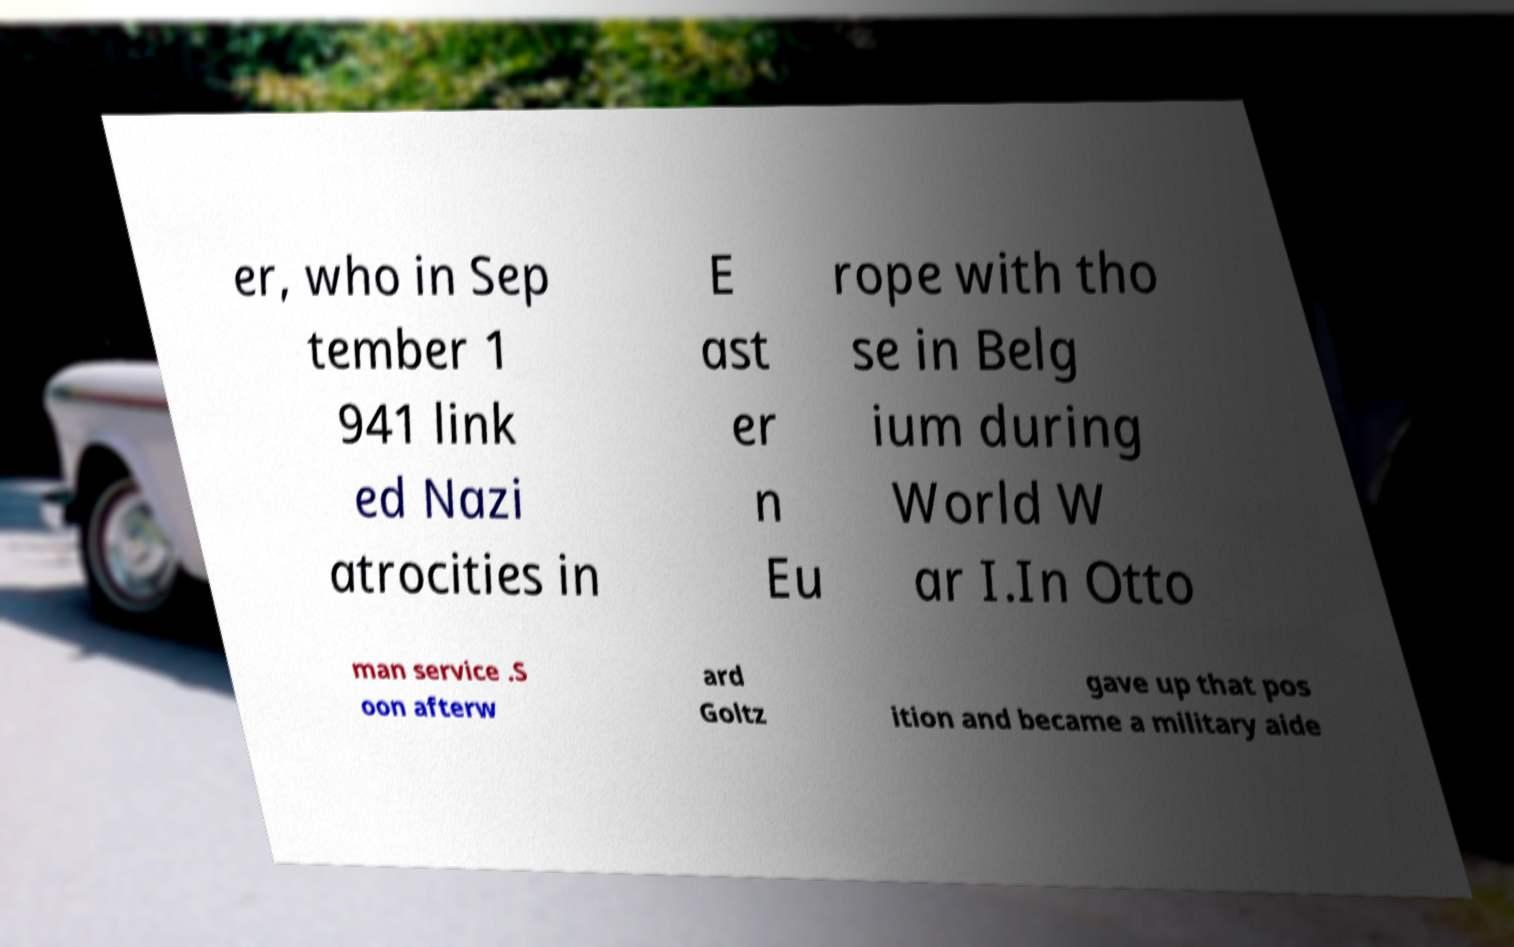Could you assist in decoding the text presented in this image and type it out clearly? er, who in Sep tember 1 941 link ed Nazi atrocities in E ast er n Eu rope with tho se in Belg ium during World W ar I.In Otto man service .S oon afterw ard Goltz gave up that pos ition and became a military aide 